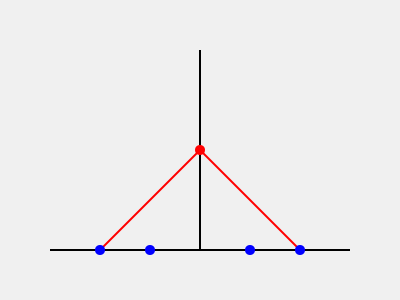In the context of Plato's Allegory of the Cave, what does the red circle at the center of the image represent, and how does it relate to the blue circles at the bottom? 1. The image represents a simplified version of Plato's Allegory of the Cave:
   - The horizontal line at the bottom represents the cave floor.
   - The vertical line represents the cave wall.
   - The red circle in the center represents the source of light (fire).
   - The blue circles at the bottom represent the prisoners.
   - The red lines from the center to the bottom represent the shadows cast by objects.

2. The red circle (fire) is crucial in the allegory because:
   - It represents the source of knowledge or truth in the physical world.
   - It casts shadows on the cave wall, which the prisoners perceive as reality.

3. The blue circles (prisoners) are significant because:
   - They represent individuals who are unaware of the true nature of reality.
   - They can only see the shadows cast by the fire, not the actual objects or the fire itself.

4. The relationship between the red circle and the blue circles illustrates:
   - The limitation of human perception when confined to a narrow worldview.
   - The difference between true knowledge (represented by the fire) and mere appearances (shadows seen by the prisoners).

5. In philosophical terms, this setup demonstrates:
   - The distinction between reality and appearance.
   - The process of enlightenment, where one must turn away from the shadows to perceive the true source of knowledge.

6. The allegory serves as a metaphor for:
   - The philosopher's role in society (to guide others towards truth).
   - The challenges of education and the acquisition of genuine knowledge.
Answer: The red circle represents the source of truth (fire), while the blue circles represent individuals with limited perception (prisoners), illustrating the gap between reality and appearance in human understanding. 